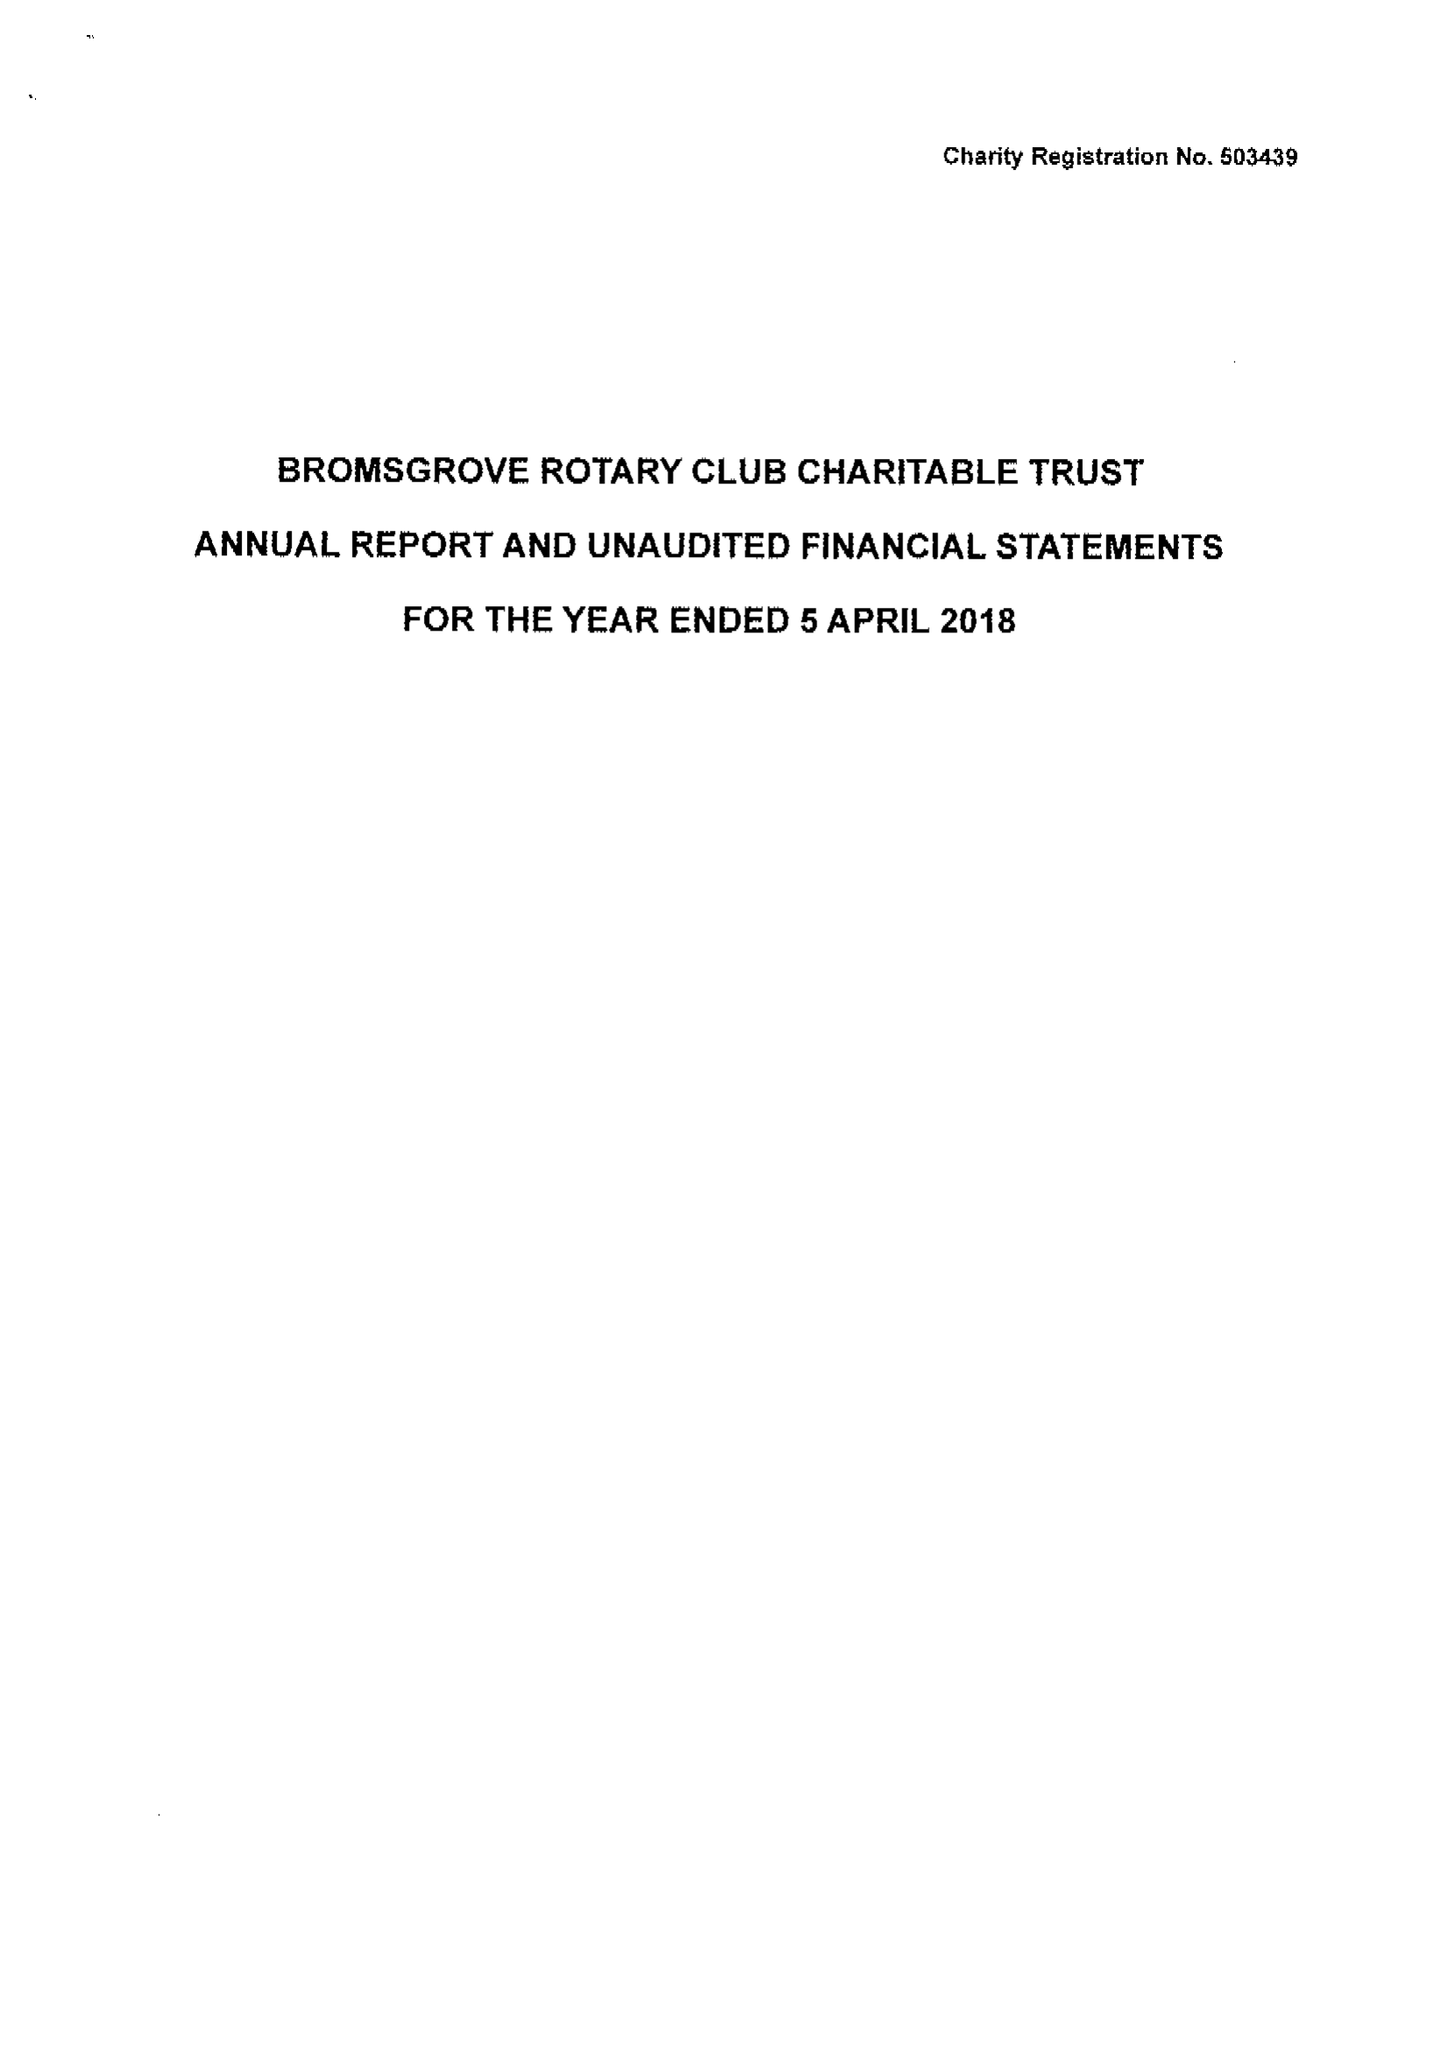What is the value for the address__street_line?
Answer the question using a single word or phrase. 4 LITTLEHEATH LANE 